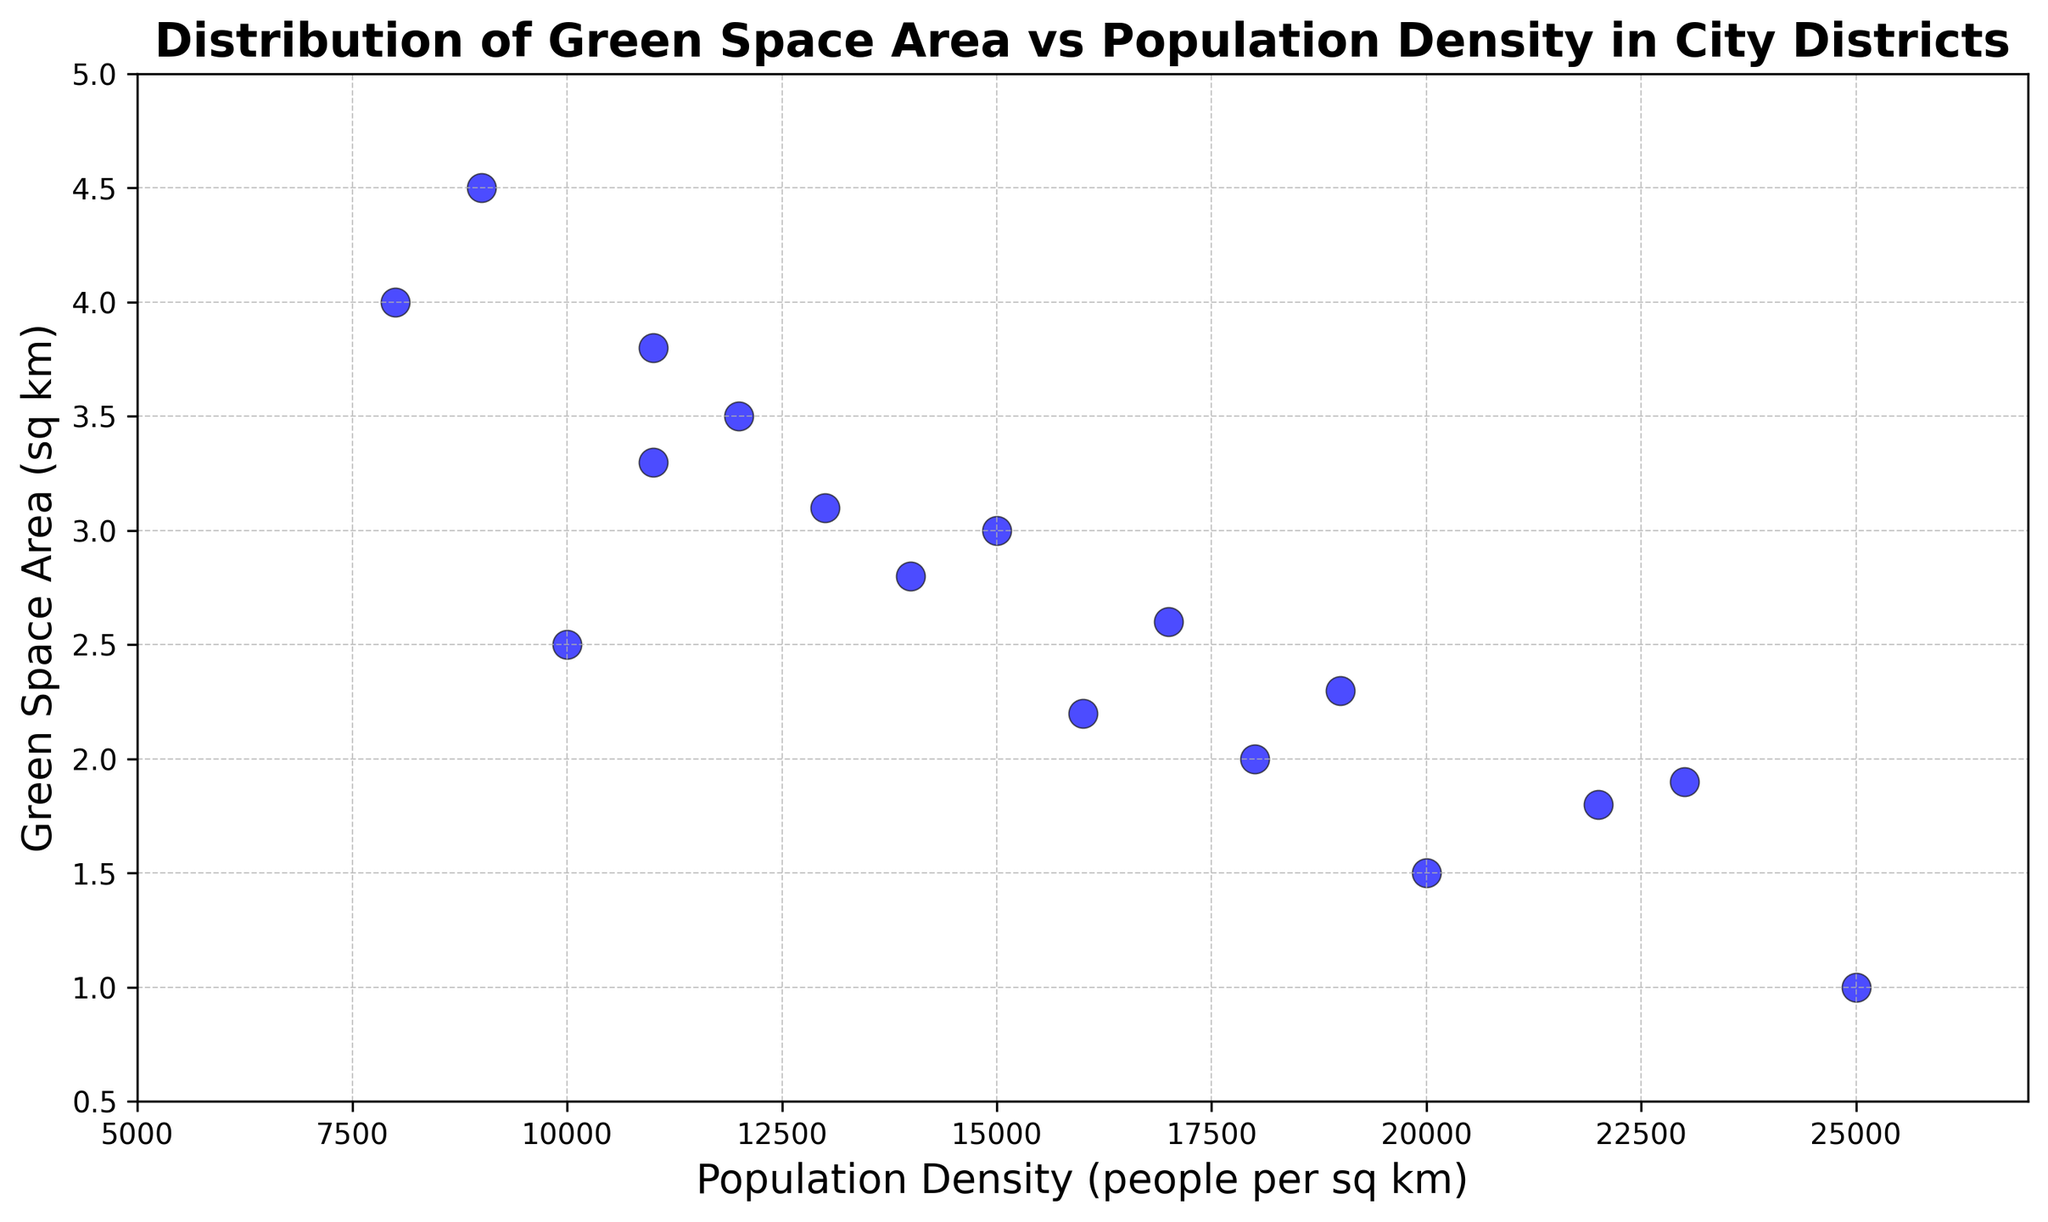What's the district with the highest green space area? By visually identifying the highest point on the y-axis (Green Space Area) in the scatter plot, we can find the corresponding district. The district with the highest green space area is around 4.5 sq km.
Answer: M Which district has the lowest population density? The district with the point farthest to the left on the x-axis (Population Density) represents the lowest population density. The lowest population density is around 8000 people per sq km.
Answer: D How many districts have a green space area greater than 3 sq km? By counting the points above the 3 sq km mark on the y-axis, we can identify how many districts meet this criterion. Districts above 3 sq km include D, E, H, M, P, and K; thus there are 6 districts.
Answer: 6 Which district has a higher green space area: District J or District L? By locating the points for Districts J and L on the plot, we compare their y-values. District J has around 2.2 sq km and District L has around 1.8 sq km, so District J has a higher green space area.
Answer: J Is there any district with both a green space area less than 2 sq km and a population density over 20000 people per sq km? Identifying districts with y-values less than 2 sq km and x-values greater than 20000 people per sq km, we see that District G (1.0, 25000) and Q (1.9, 23000) meet this criterion.
Answer: Yes, G and Q What is the average green space area of districts with a population density between 10000 and 15000? First, identify the districts within the population density range of 10000 to 15000. These districts are A, P, H, B, and I. Their green space areas are 2.5, 3.3, 3.8, 3.0, and 2.8 respectively. The average is (2.5 + 3.3 + 3.8 + 3.0 + 2.8) / 5 = 3.1 sq km.
Answer: 3.1 Which district has the highest green space area in districts with a population density less than 12000? We consider districts with population density less than 12000. These districts include A, D, M, E, H, and P. Among these, the highest green space area is M with 4.5 sq km.
Answer: M Are there more districts with green space areas below 2 sq km or above 4 sq km? Count the points below 2 sq km and above 4 sq km on the y-axis. Districts below 2 sq km are C, F, G, J, L, and Q (6 districts). Districts above 4 sq km are D and M (2 districts).
Answer: Below 2 sq km Which district is an outlier in terms of having a high population density but low green space area? An outlier would be a district with an unusually high population density but a comparably low green space area. District G stands out with 25000 people per sq km and only 1.0 sq km of green space.
Answer: G What is the combined green space area of districts with a population density greater than 20000? Identify the districts with a population density greater than 20000: G (1.0 sq km), L (1.8 sq km), and Q (1.9 sq km). Summing their green space areas gives 1.0 + 1.8 + 1.9 = 4.7 sq km.
Answer: 4.7 